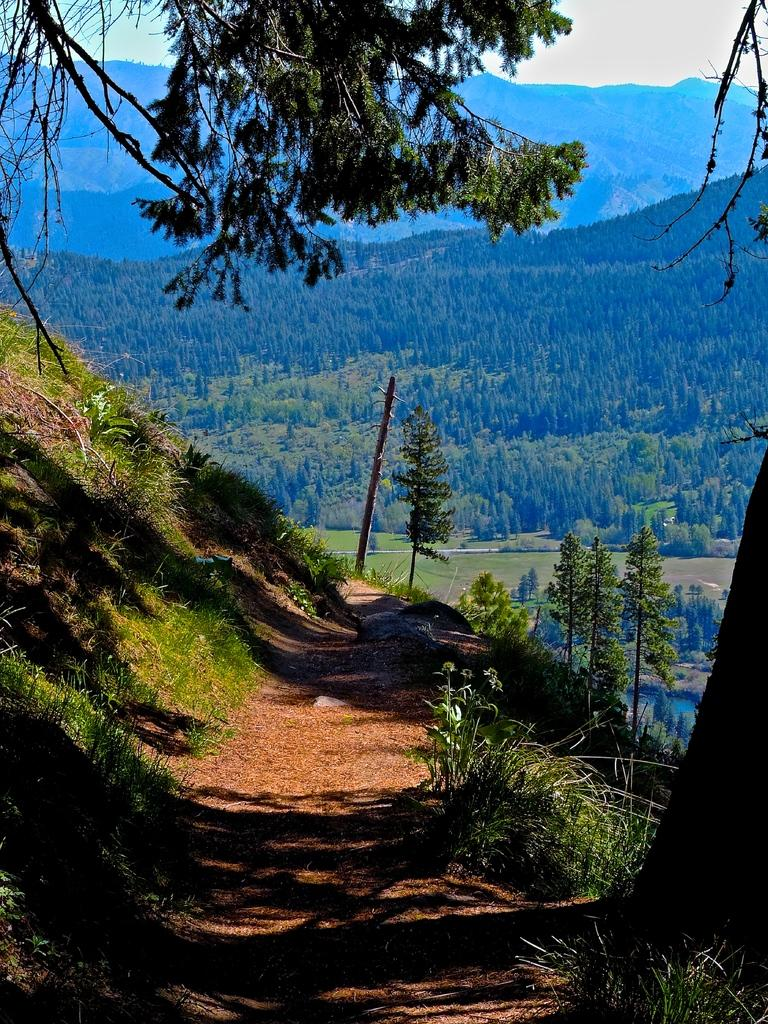What type of vegetation is present in the image? There is grass in the image. What other natural elements can be seen in the image? There is a tree in the image. What can be seen in the background of the image? There are trees and hills in the background of the image. What part of the natural environment is visible in the background of the image? The sky is visible in the background of the image. What type of flesh can be seen on the tree in the image? There is no flesh present on the tree in the image; it is a natural element with bark and leaves. 